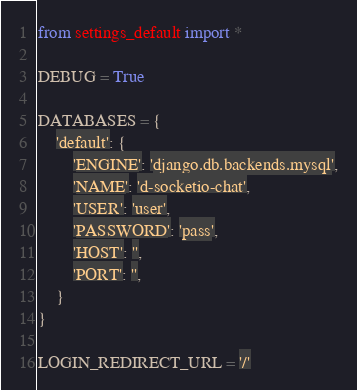<code> <loc_0><loc_0><loc_500><loc_500><_Python_>from settings_default import *

DEBUG = True

DATABASES = {
    'default': {
        'ENGINE': 'django.db.backends.mysql',
        'NAME': 'd-socketio-chat',
        'USER': 'user',
        'PASSWORD': 'pass',
        'HOST': '',
        'PORT': '',
    }
}

LOGIN_REDIRECT_URL = '/'
</code> 